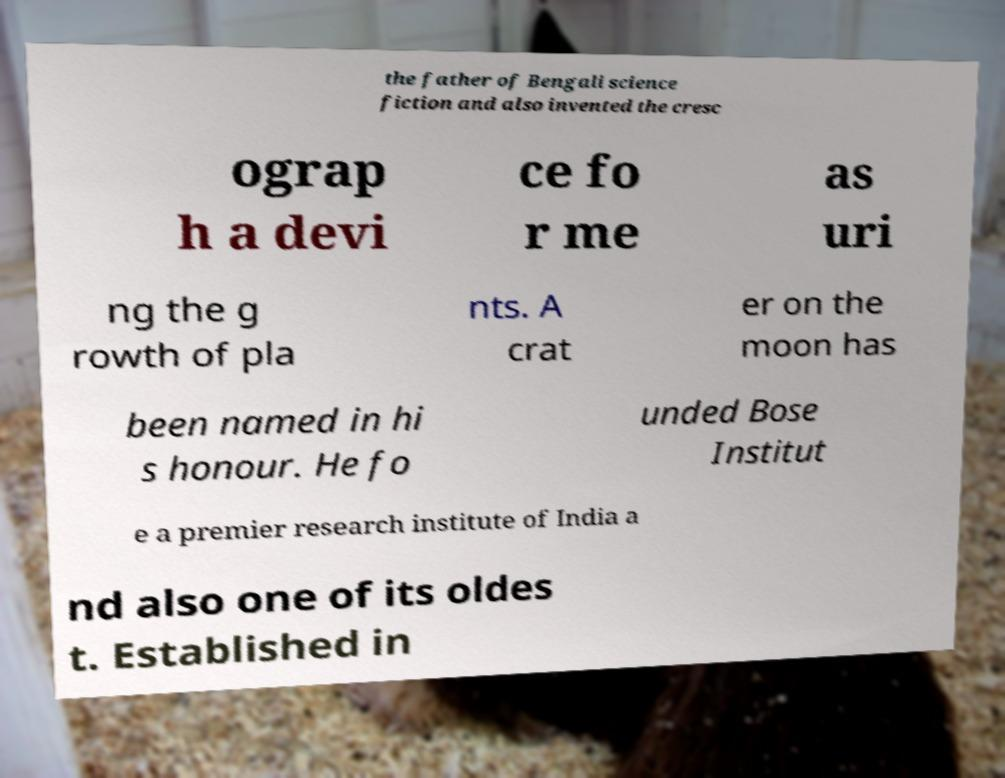Please identify and transcribe the text found in this image. the father of Bengali science fiction and also invented the cresc ograp h a devi ce fo r me as uri ng the g rowth of pla nts. A crat er on the moon has been named in hi s honour. He fo unded Bose Institut e a premier research institute of India a nd also one of its oldes t. Established in 